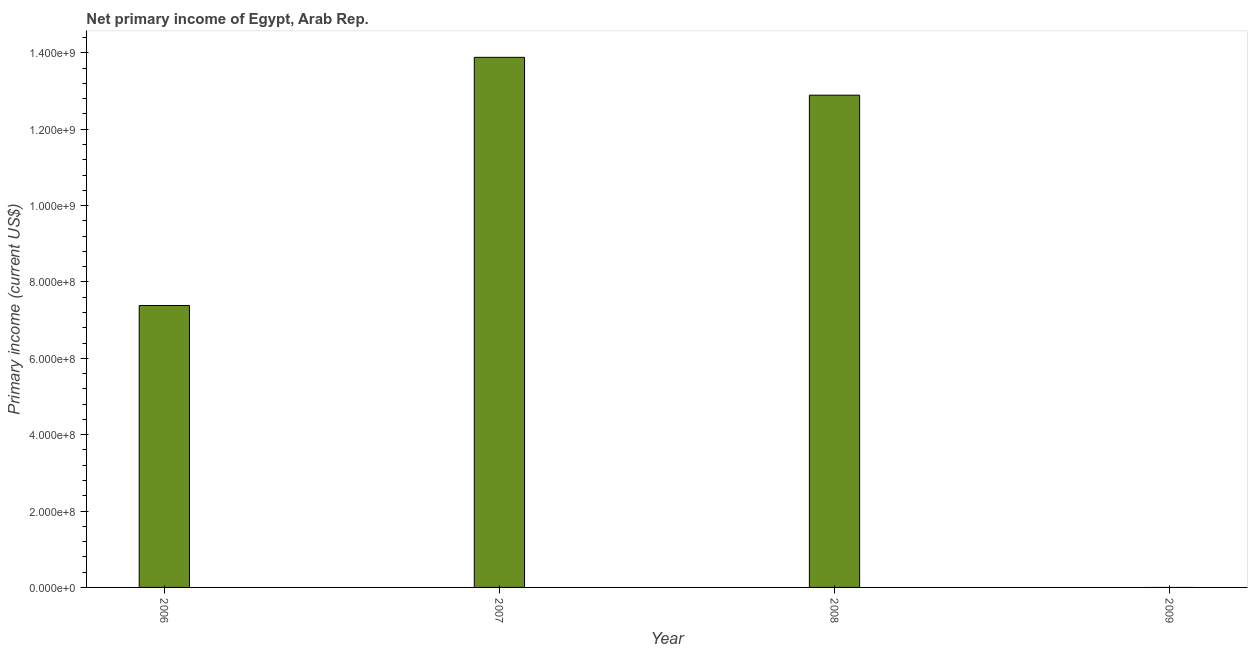Does the graph contain grids?
Offer a very short reply. No. What is the title of the graph?
Your response must be concise. Net primary income of Egypt, Arab Rep. What is the label or title of the X-axis?
Keep it short and to the point. Year. What is the label or title of the Y-axis?
Your answer should be very brief. Primary income (current US$). What is the amount of primary income in 2006?
Your answer should be very brief. 7.38e+08. Across all years, what is the maximum amount of primary income?
Offer a very short reply. 1.39e+09. Across all years, what is the minimum amount of primary income?
Keep it short and to the point. 0. In which year was the amount of primary income maximum?
Keep it short and to the point. 2007. What is the sum of the amount of primary income?
Ensure brevity in your answer.  3.42e+09. What is the difference between the amount of primary income in 2007 and 2008?
Your response must be concise. 9.91e+07. What is the average amount of primary income per year?
Offer a terse response. 8.54e+08. What is the median amount of primary income?
Offer a terse response. 1.01e+09. What is the ratio of the amount of primary income in 2006 to that in 2008?
Keep it short and to the point. 0.57. What is the difference between the highest and the second highest amount of primary income?
Make the answer very short. 9.91e+07. What is the difference between the highest and the lowest amount of primary income?
Ensure brevity in your answer.  1.39e+09. How many bars are there?
Ensure brevity in your answer.  3. Are all the bars in the graph horizontal?
Offer a terse response. No. How many years are there in the graph?
Offer a terse response. 4. What is the difference between two consecutive major ticks on the Y-axis?
Your response must be concise. 2.00e+08. What is the Primary income (current US$) in 2006?
Make the answer very short. 7.38e+08. What is the Primary income (current US$) of 2007?
Ensure brevity in your answer.  1.39e+09. What is the Primary income (current US$) in 2008?
Keep it short and to the point. 1.29e+09. What is the Primary income (current US$) in 2009?
Offer a terse response. 0. What is the difference between the Primary income (current US$) in 2006 and 2007?
Make the answer very short. -6.50e+08. What is the difference between the Primary income (current US$) in 2006 and 2008?
Keep it short and to the point. -5.51e+08. What is the difference between the Primary income (current US$) in 2007 and 2008?
Your response must be concise. 9.91e+07. What is the ratio of the Primary income (current US$) in 2006 to that in 2007?
Provide a short and direct response. 0.53. What is the ratio of the Primary income (current US$) in 2006 to that in 2008?
Keep it short and to the point. 0.57. What is the ratio of the Primary income (current US$) in 2007 to that in 2008?
Provide a short and direct response. 1.08. 